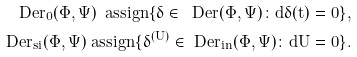Convert formula to latex. <formula><loc_0><loc_0><loc_500><loc_500>\ D e r _ { 0 } ( \Phi , \Psi ) \ a s s i g n \{ \delta \in \ D e r ( \Phi , \Psi ) \colon d \delta ( t ) = 0 \} , \\ \ D e r _ { s i } ( \Phi , \Psi ) \ a s s i g n \{ \delta ^ { ( U ) } \in \ D e r _ { i n } ( \Phi , \Psi ) \colon d U = 0 \} .</formula> 